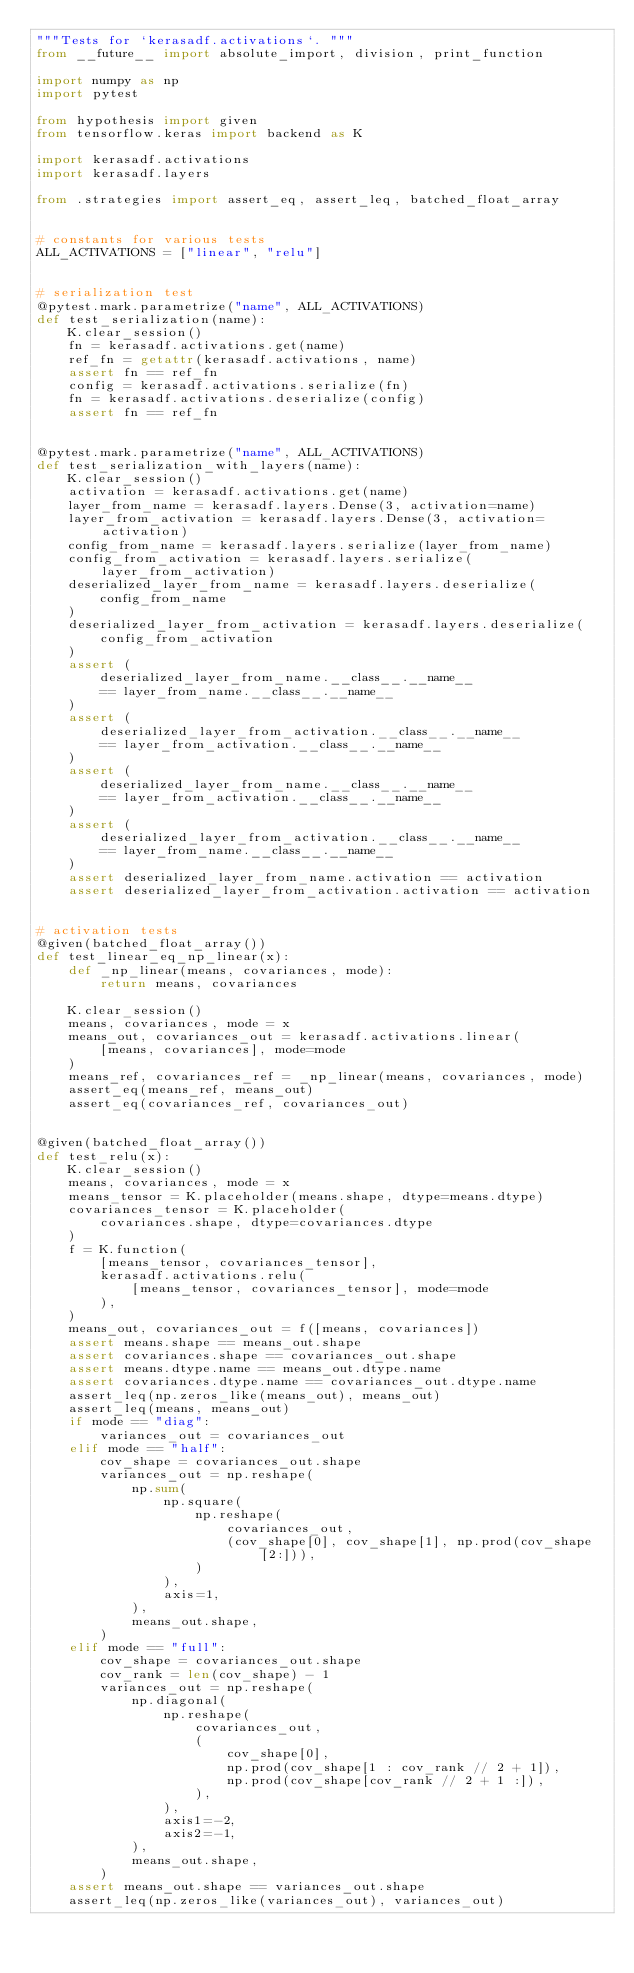Convert code to text. <code><loc_0><loc_0><loc_500><loc_500><_Python_>"""Tests for `kerasadf.activations`. """
from __future__ import absolute_import, division, print_function

import numpy as np
import pytest

from hypothesis import given
from tensorflow.keras import backend as K

import kerasadf.activations
import kerasadf.layers

from .strategies import assert_eq, assert_leq, batched_float_array


# constants for various tests
ALL_ACTIVATIONS = ["linear", "relu"]


# serialization test
@pytest.mark.parametrize("name", ALL_ACTIVATIONS)
def test_serialization(name):
    K.clear_session()
    fn = kerasadf.activations.get(name)
    ref_fn = getattr(kerasadf.activations, name)
    assert fn == ref_fn
    config = kerasadf.activations.serialize(fn)
    fn = kerasadf.activations.deserialize(config)
    assert fn == ref_fn


@pytest.mark.parametrize("name", ALL_ACTIVATIONS)
def test_serialization_with_layers(name):
    K.clear_session()
    activation = kerasadf.activations.get(name)
    layer_from_name = kerasadf.layers.Dense(3, activation=name)
    layer_from_activation = kerasadf.layers.Dense(3, activation=activation)
    config_from_name = kerasadf.layers.serialize(layer_from_name)
    config_from_activation = kerasadf.layers.serialize(layer_from_activation)
    deserialized_layer_from_name = kerasadf.layers.deserialize(
        config_from_name
    )
    deserialized_layer_from_activation = kerasadf.layers.deserialize(
        config_from_activation
    )
    assert (
        deserialized_layer_from_name.__class__.__name__
        == layer_from_name.__class__.__name__
    )
    assert (
        deserialized_layer_from_activation.__class__.__name__
        == layer_from_activation.__class__.__name__
    )
    assert (
        deserialized_layer_from_name.__class__.__name__
        == layer_from_activation.__class__.__name__
    )
    assert (
        deserialized_layer_from_activation.__class__.__name__
        == layer_from_name.__class__.__name__
    )
    assert deserialized_layer_from_name.activation == activation
    assert deserialized_layer_from_activation.activation == activation


# activation tests
@given(batched_float_array())
def test_linear_eq_np_linear(x):
    def _np_linear(means, covariances, mode):
        return means, covariances

    K.clear_session()
    means, covariances, mode = x
    means_out, covariances_out = kerasadf.activations.linear(
        [means, covariances], mode=mode
    )
    means_ref, covariances_ref = _np_linear(means, covariances, mode)
    assert_eq(means_ref, means_out)
    assert_eq(covariances_ref, covariances_out)


@given(batched_float_array())
def test_relu(x):
    K.clear_session()
    means, covariances, mode = x
    means_tensor = K.placeholder(means.shape, dtype=means.dtype)
    covariances_tensor = K.placeholder(
        covariances.shape, dtype=covariances.dtype
    )
    f = K.function(
        [means_tensor, covariances_tensor],
        kerasadf.activations.relu(
            [means_tensor, covariances_tensor], mode=mode
        ),
    )
    means_out, covariances_out = f([means, covariances])
    assert means.shape == means_out.shape
    assert covariances.shape == covariances_out.shape
    assert means.dtype.name == means_out.dtype.name
    assert covariances.dtype.name == covariances_out.dtype.name
    assert_leq(np.zeros_like(means_out), means_out)
    assert_leq(means, means_out)
    if mode == "diag":
        variances_out = covariances_out
    elif mode == "half":
        cov_shape = covariances_out.shape
        variances_out = np.reshape(
            np.sum(
                np.square(
                    np.reshape(
                        covariances_out,
                        (cov_shape[0], cov_shape[1], np.prod(cov_shape[2:])),
                    )
                ),
                axis=1,
            ),
            means_out.shape,
        )
    elif mode == "full":
        cov_shape = covariances_out.shape
        cov_rank = len(cov_shape) - 1
        variances_out = np.reshape(
            np.diagonal(
                np.reshape(
                    covariances_out,
                    (
                        cov_shape[0],
                        np.prod(cov_shape[1 : cov_rank // 2 + 1]),
                        np.prod(cov_shape[cov_rank // 2 + 1 :]),
                    ),
                ),
                axis1=-2,
                axis2=-1,
            ),
            means_out.shape,
        )
    assert means_out.shape == variances_out.shape
    assert_leq(np.zeros_like(variances_out), variances_out)
</code> 